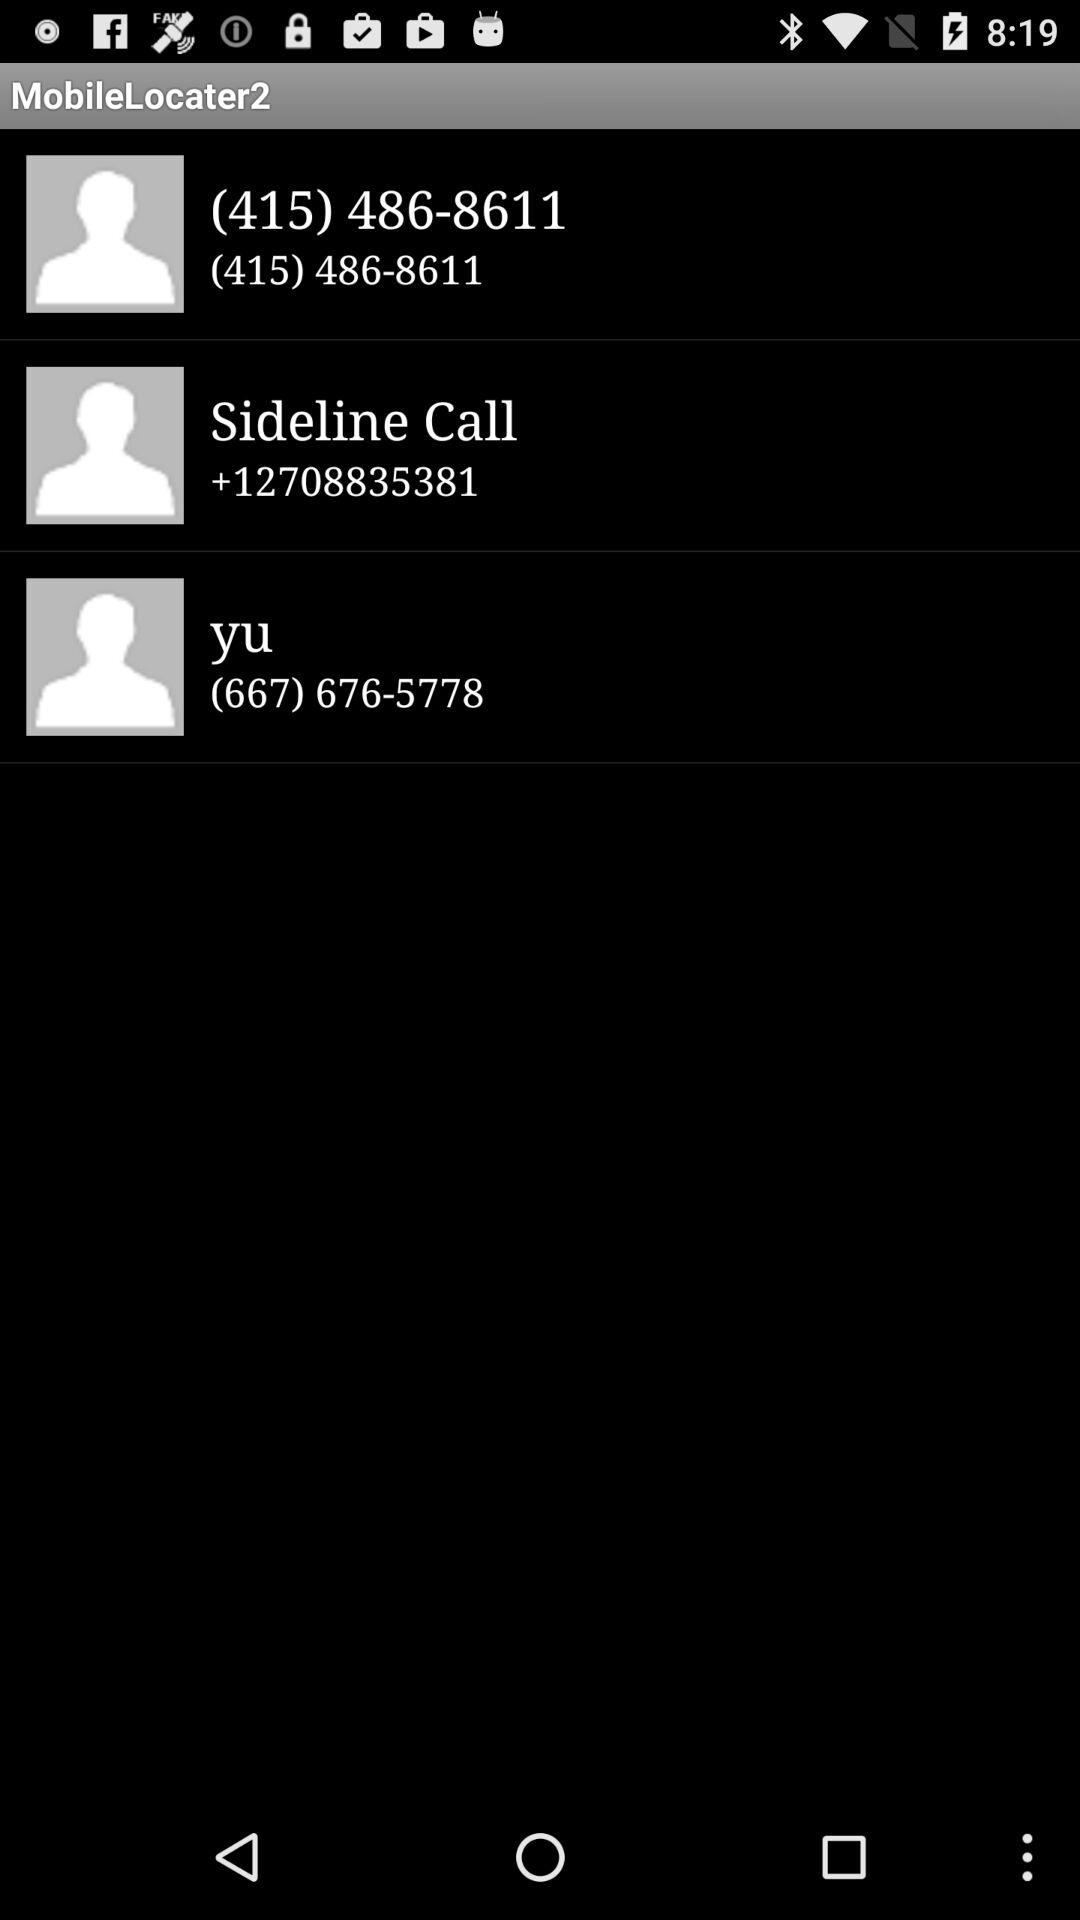What is the contact number for "Sideline Call"? The contact number for "Sideline Call" is +12708835381. 